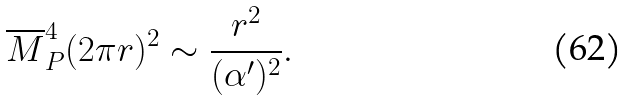Convert formula to latex. <formula><loc_0><loc_0><loc_500><loc_500>\overline { M } _ { P } ^ { 4 } ( 2 \pi r ) ^ { 2 } \sim \frac { r ^ { 2 } } { ( \alpha ^ { \prime } ) ^ { 2 } } .</formula> 